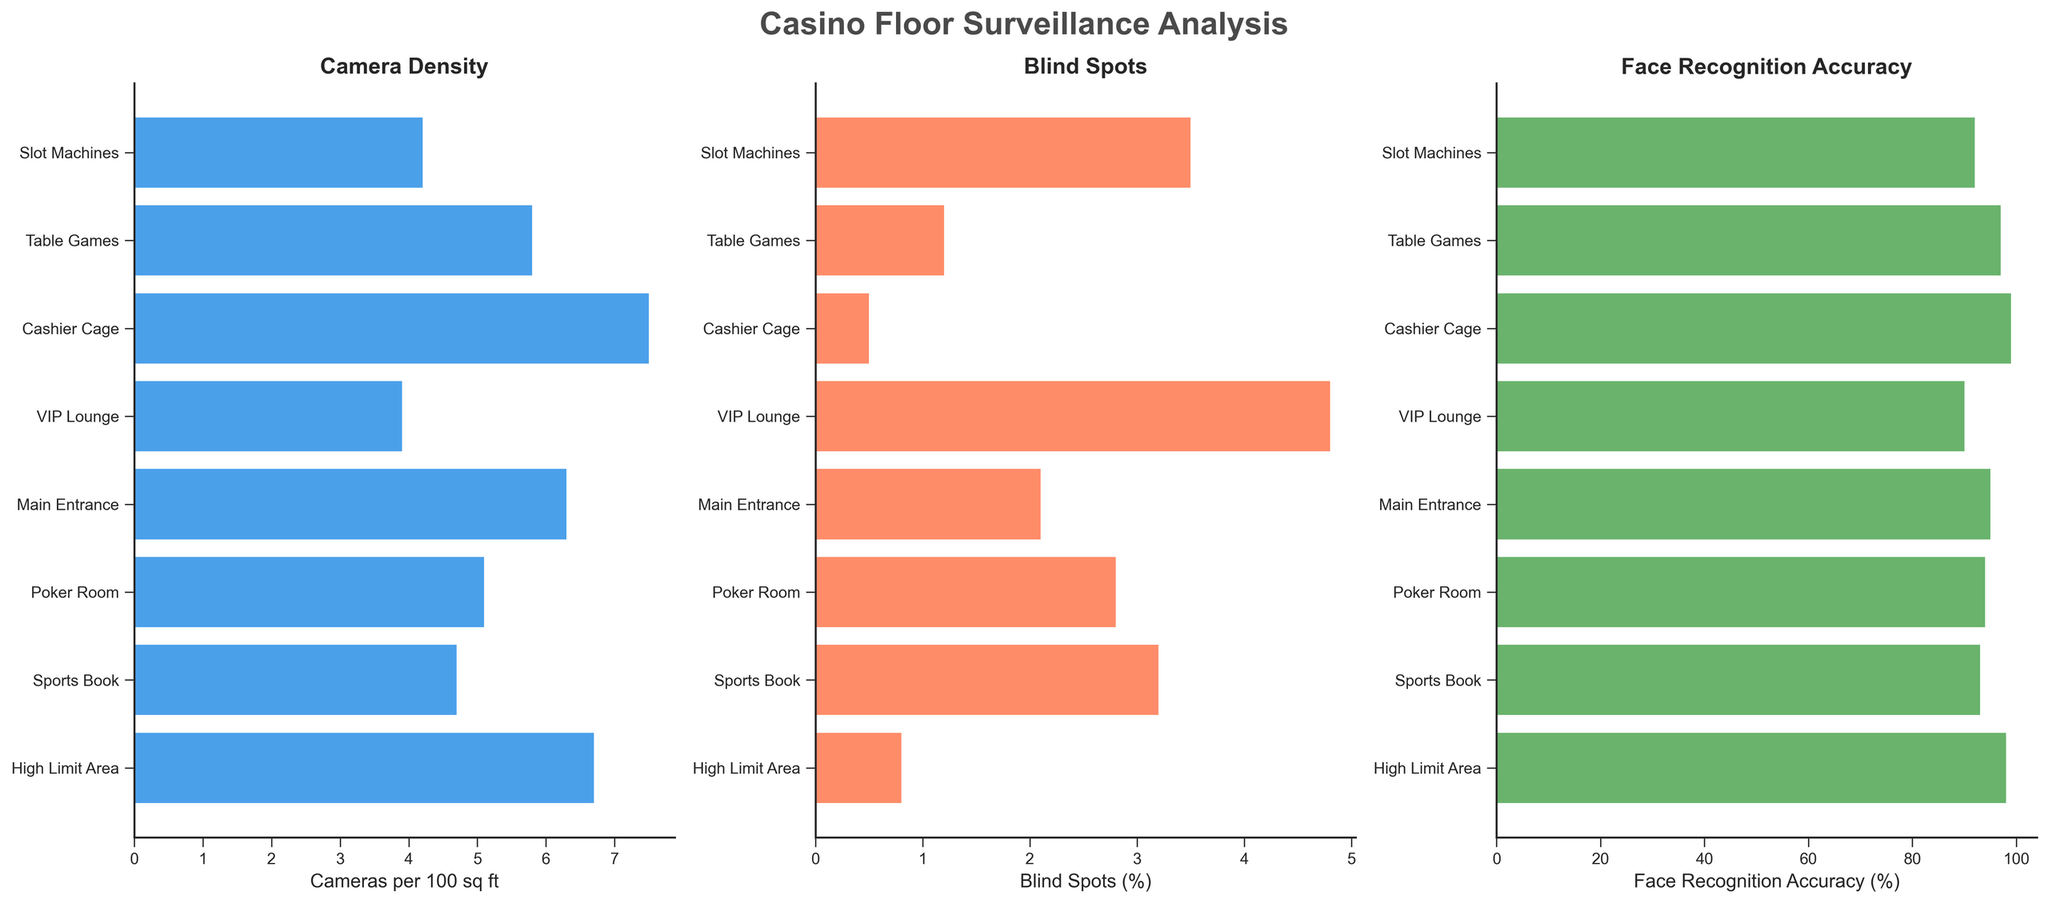Which area has the highest density of cameras per 100 sq ft? From the first subplot, look for the area with the longest blue bar. The 'Cashier Cage' has the longest bar, indicating the highest camera density.
Answer: Cashier Cage Which two areas have the smallest percentage of blind spots? From the second subplot, identify the two shortest orange bars. The 'Cashier Cage' and the 'High Limit Area' have the shortest bars, indicating the smallest percentage of blind spots.
Answer: Cashier Cage, High Limit Area What is the difference in face recognition accuracy (%) between the 'VIP Lounge' and the 'Table Games'? From the third subplot, read the face recognition accuracy for 'VIP Lounge' (90%) and 'Table Games' (97%) and then calculate the difference (97% - 90%).
Answer: 7% Compare the cameras per 100 sq ft in the 'Slot Machines' area to the 'High Limit Area'. Which one has more, and by how much? Look at the first subplot. 'Slot Machines' has 4.2 cameras and 'High Limit Area' has 6.7 cameras. Calculate the difference (6.7 - 4.2).
Answer: High Limit Area, 2.5 What is the average blind spot percentage across all areas? Add up all the percentages of blind spots from the second subplot (3.5 + 1.2 + 0.5 + 4.8 + 2.1 + 2.8 + 3.2 + 0.8) to get 18.9%. Divide by the number of areas (8).
Answer: 2.36% Identify the area with the lowest face recognition accuracy. From the third subplot, find the shortest green bar. The 'VIP Lounge' has the lowest face recognition accuracy.
Answer: VIP Lounge How does the camera density in the 'Poker Room' compare to the 'Main Entrance'? In the first subplot, compare 'Poker Room' (5.1 cameras) to the 'Main Entrance' (6.3 cameras). 'Main Entrance' has more cameras than the 'Poker Room'.
Answer: Main Entrance Rank the areas by the percentage of blind spots from lowest to highest. Order the percentages from the second subplot: 0.5 (Cashier Cage), 0.8 (High Limit Area), 1.2 (Table Games), 2.1 (Main Entrance), 2.8 (Poker Room), 3.2 (Sports Book), 3.5 (Slot Machines), 4.8 (VIP Lounge).
Answer: Cashier Cage, High Limit Area, Table Games, Main Entrance, Poker Room, Sports Book, Slot Machines, VIP Lounge Is there any area where the cameras per 100 sq ft and face recognition accuracy both rank high? Look at areas with high values in the first (camera density) and third (face recognition) subplots. The 'Cashier Cage' has high values in both plots.
Answer: Cashier Cage 